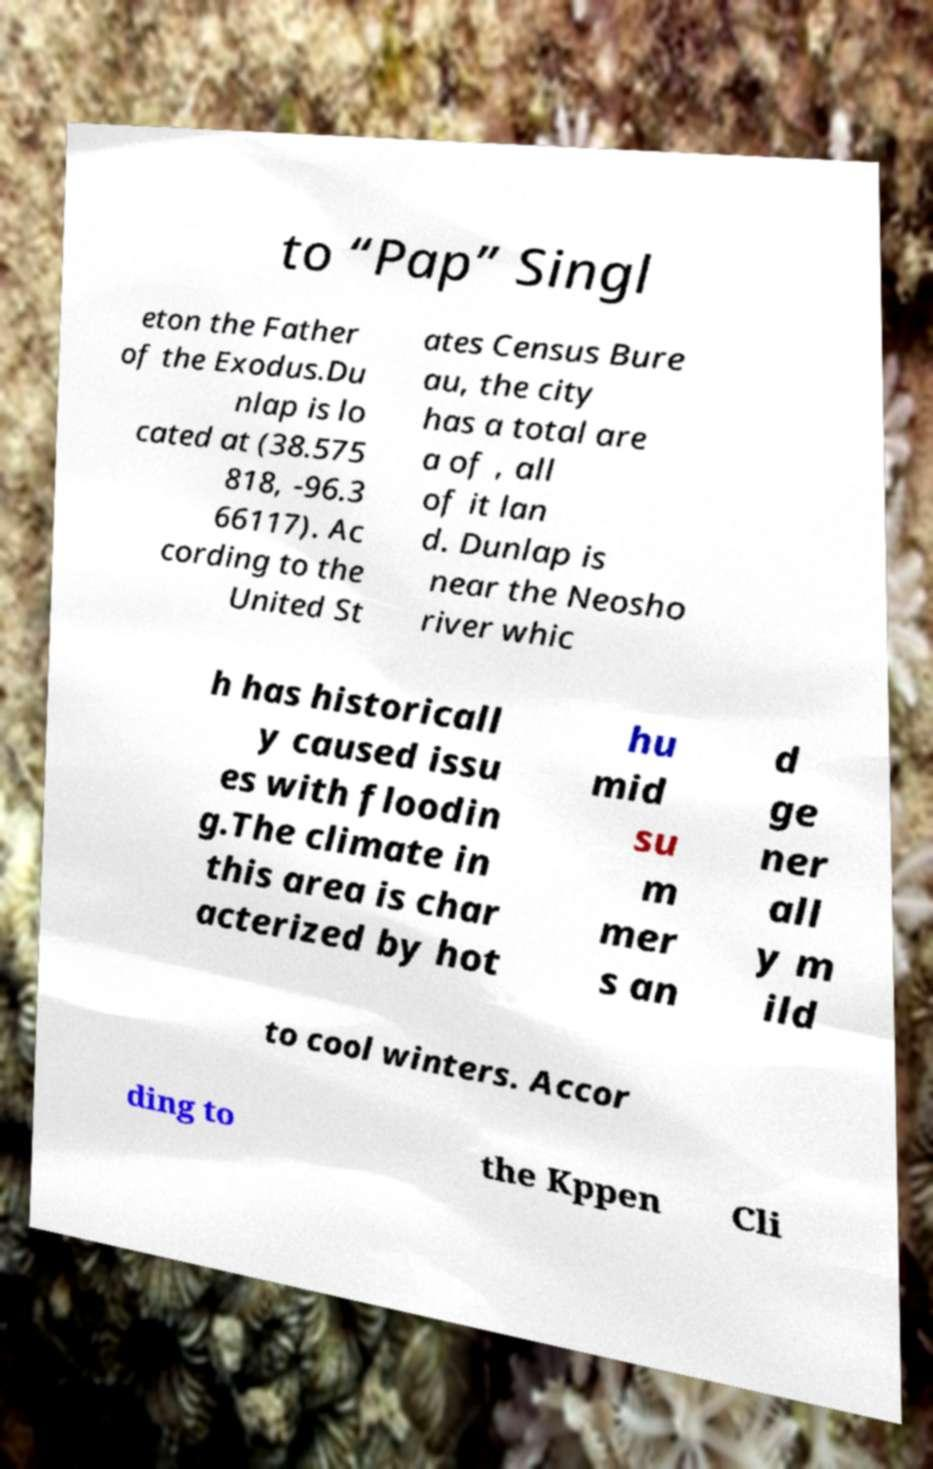For documentation purposes, I need the text within this image transcribed. Could you provide that? to “Pap” Singl eton the Father of the Exodus.Du nlap is lo cated at (38.575 818, -96.3 66117). Ac cording to the United St ates Census Bure au, the city has a total are a of , all of it lan d. Dunlap is near the Neosho river whic h has historicall y caused issu es with floodin g.The climate in this area is char acterized by hot hu mid su m mer s an d ge ner all y m ild to cool winters. Accor ding to the Kppen Cli 